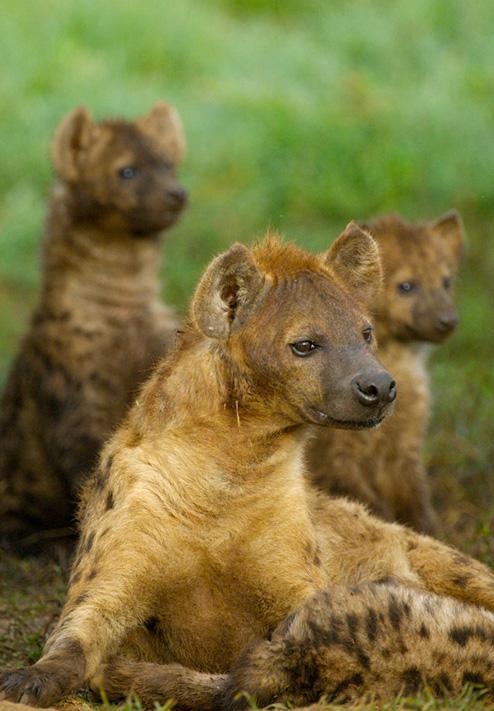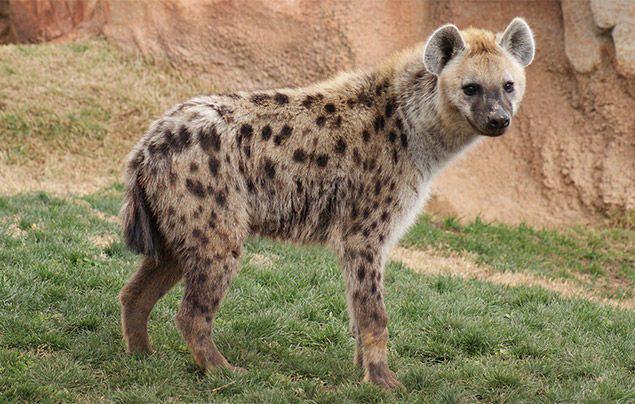The first image is the image on the left, the second image is the image on the right. Assess this claim about the two images: "One image contains a single hyena.". Correct or not? Answer yes or no. Yes. 